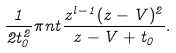<formula> <loc_0><loc_0><loc_500><loc_500>\frac { 1 } { 2 t _ { 0 } ^ { 2 } } \pi n t \frac { z ^ { l - 1 } ( z - V ) ^ { 2 } } { z - V + t _ { 0 } } .</formula> 